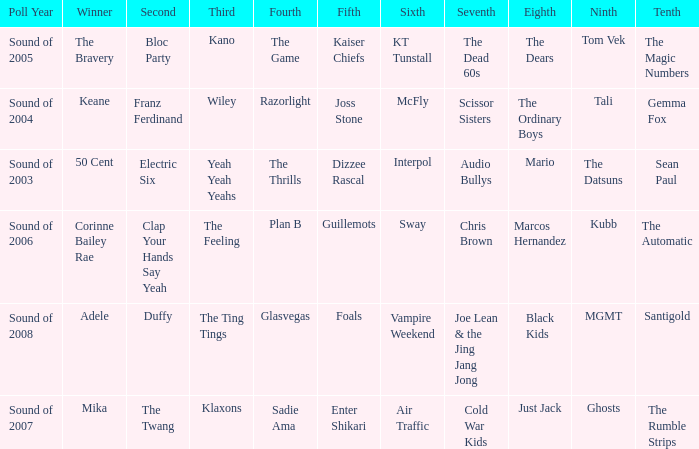How many times was Plan B 4th place? 1.0. 